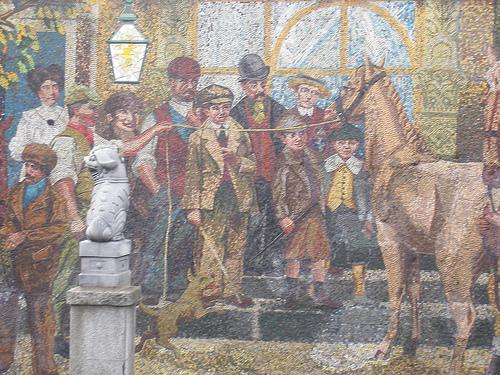Question: what is this object?
Choices:
A. Painting.
B. Window.
C. Mirror.
D. Note.
Answer with the letter. Answer: A Question: what is the person in the painting holding by a string?
Choices:
A. Kite.
B. Dog.
C. Duck.
D. Horse.
Answer with the letter. Answer: D Question: how many horses are in the photo?
Choices:
A. Two.
B. One.
C. Three.
D. Seven.
Answer with the letter. Answer: B Question: where is this painting?
Choices:
A. At the museum.
B. On a shelf.
C. On a wall.
D. On a table.
Answer with the letter. Answer: C Question: what is the statue in front of the painting made of?
Choices:
A. Marble.
B. Stone.
C. Clay.
D. Paper mache.
Answer with the letter. Answer: B Question: where is this scene taking place?
Choices:
A. Behind the building.
B. In front of building.
C. On Top of the building.
D. Underneath the building.
Answer with the letter. Answer: B 